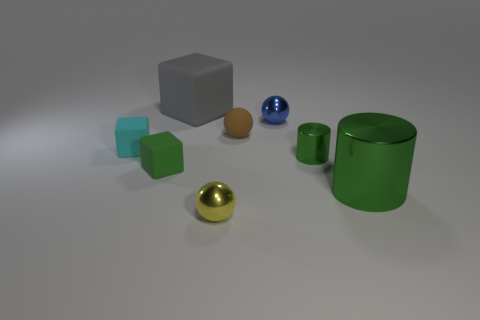Add 1 balls. How many objects exist? 9 Subtract all cylinders. How many objects are left? 6 Subtract 2 green cylinders. How many objects are left? 6 Subtract all large green objects. Subtract all brown things. How many objects are left? 6 Add 7 small green objects. How many small green objects are left? 9 Add 8 matte balls. How many matte balls exist? 9 